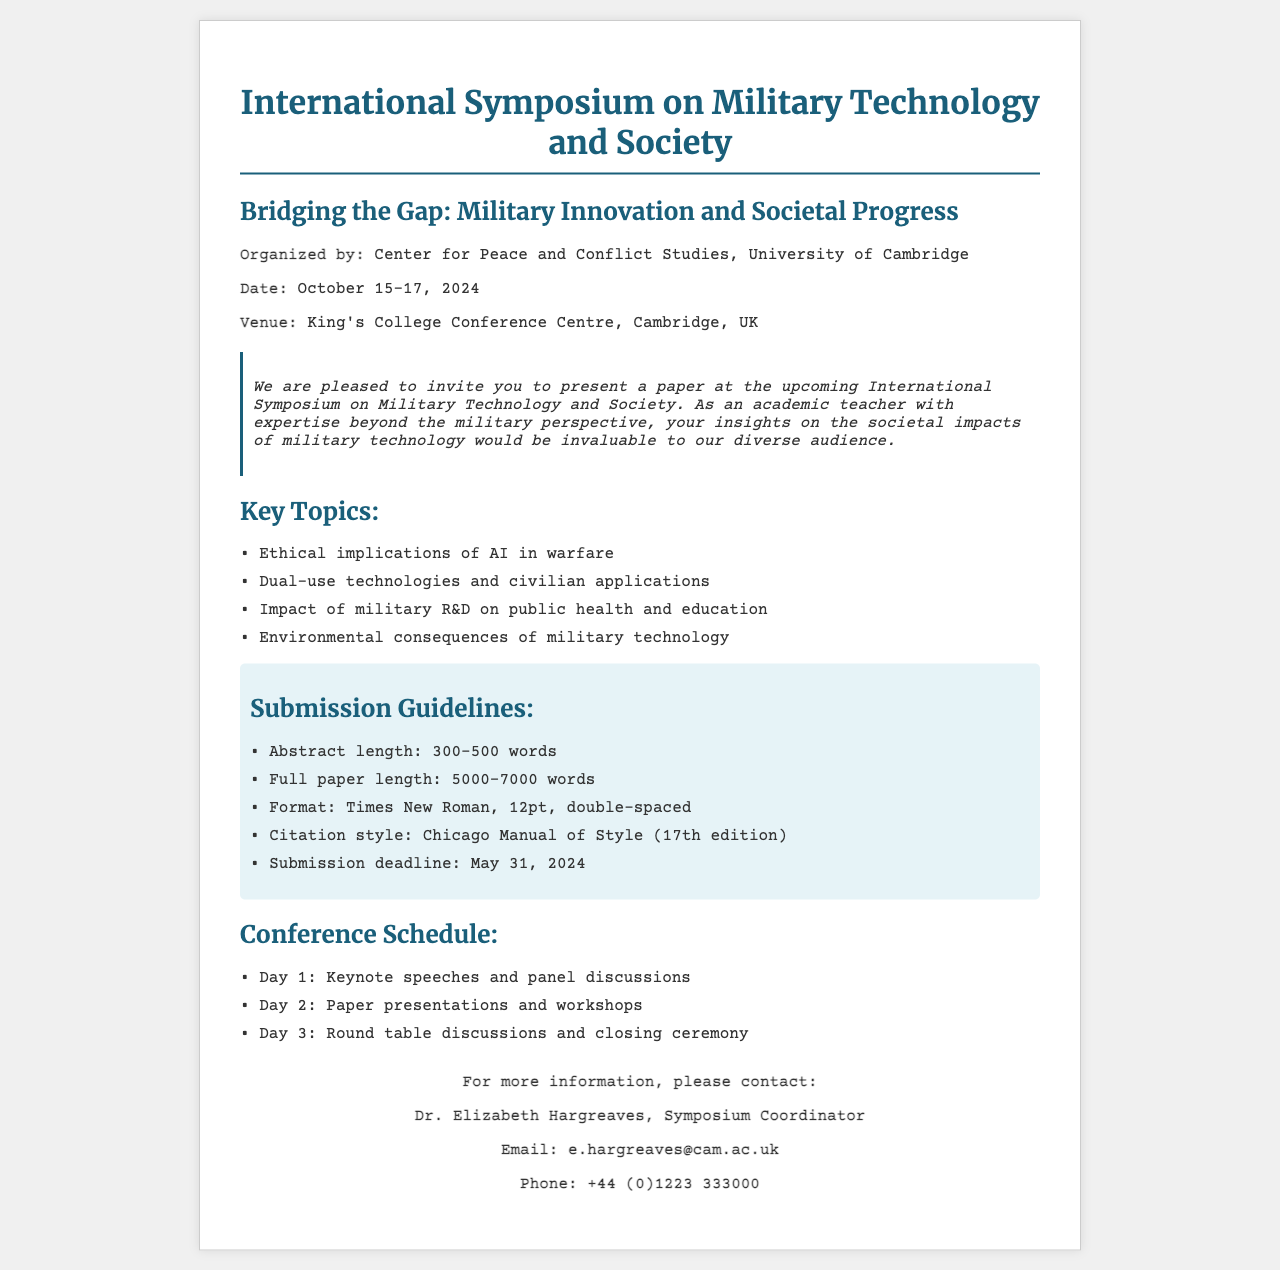What is the name of the symposium? The document mentions the symposium as the "International Symposium on Military Technology and Society."
Answer: International Symposium on Military Technology and Society What are the dates of the conference? The document states that the conference is scheduled for October 15-17, 2024.
Answer: October 15-17, 2024 Who is organizing the symposium? The organizing body mentioned in the document is the "Center for Peace and Conflict Studies, University of Cambridge."
Answer: Center for Peace and Conflict Studies, University of Cambridge What is the submission deadline for papers? According to the document, the submission deadline is May 31, 2024.
Answer: May 31, 2024 How long should the abstract be? The document specifies that the abstract length should be between 300-500 words.
Answer: 300-500 words What is one key topic mentioned for paper submissions? The document lists several topics, one of which is the "Ethical implications of AI in warfare."
Answer: Ethical implications of AI in warfare What is the citation style required for submissions? The document states that the required citation style is the "Chicago Manual of Style (17th edition)."
Answer: Chicago Manual of Style (17th edition) What type of events are scheduled for Day 1 of the conference? The document mentions that Day 1 will include "Keynote speeches and panel discussions."
Answer: Keynote speeches and panel discussions Who should be contacted for more information? As per the document, inquiries should be directed to "Dr. Elizabeth Hargreaves, Symposium Coordinator."
Answer: Dr. Elizabeth Hargreaves, Symposium Coordinator 